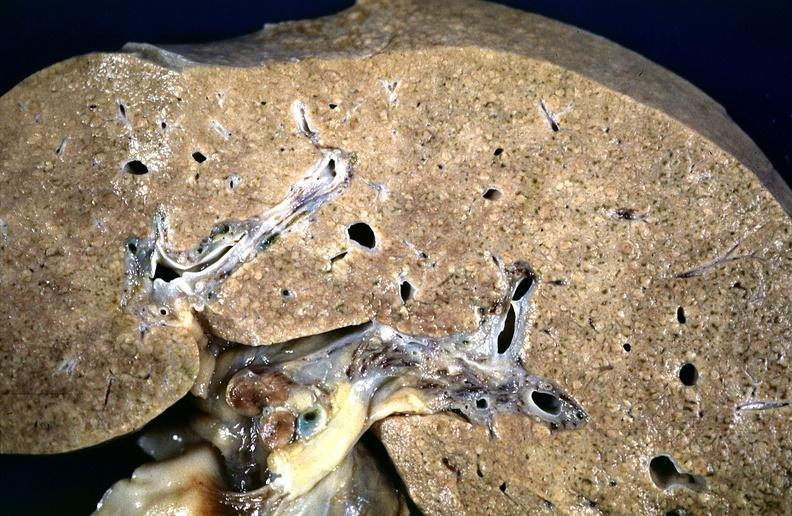does mucoepidermoid carcinoma show cirrhosis?
Answer the question using a single word or phrase. No 